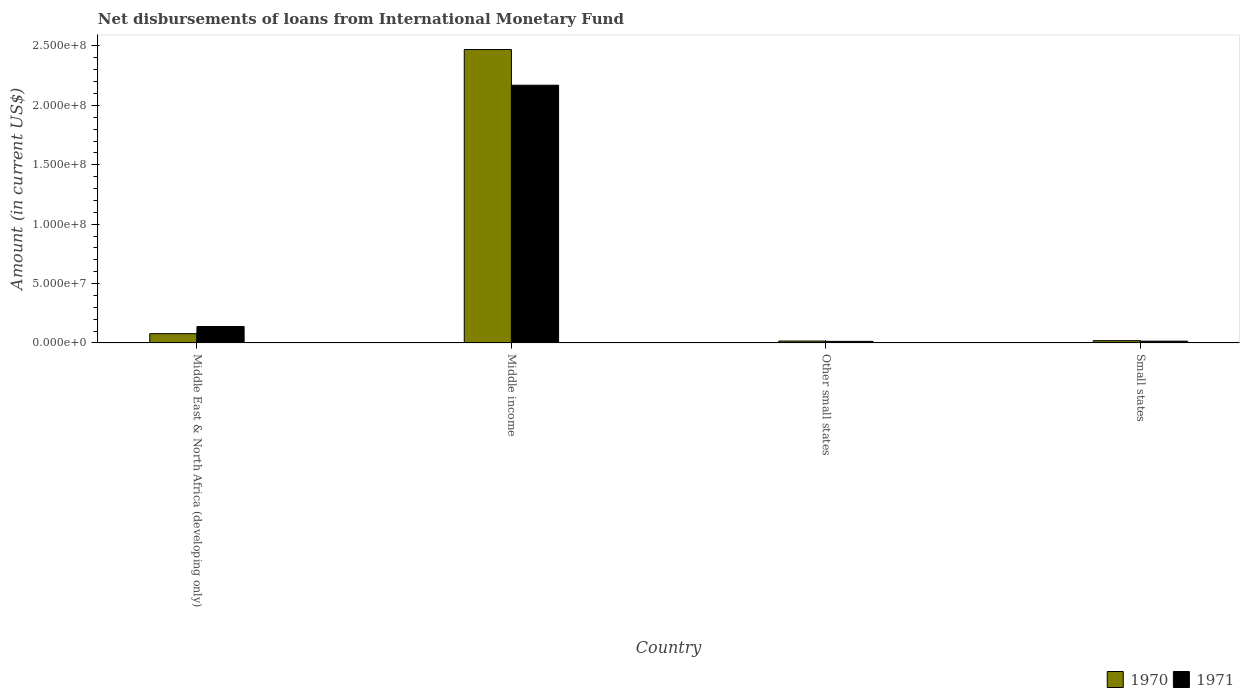How many different coloured bars are there?
Your response must be concise. 2. Are the number of bars per tick equal to the number of legend labels?
Provide a succinct answer. Yes. Are the number of bars on each tick of the X-axis equal?
Offer a terse response. Yes. What is the label of the 3rd group of bars from the left?
Make the answer very short. Other small states. What is the amount of loans disbursed in 1970 in Small states?
Ensure brevity in your answer.  1.91e+06. Across all countries, what is the maximum amount of loans disbursed in 1971?
Provide a succinct answer. 2.17e+08. Across all countries, what is the minimum amount of loans disbursed in 1970?
Provide a succinct answer. 1.61e+06. In which country was the amount of loans disbursed in 1971 minimum?
Your answer should be very brief. Other small states. What is the total amount of loans disbursed in 1970 in the graph?
Your answer should be compact. 2.58e+08. What is the difference between the amount of loans disbursed in 1971 in Middle East & North Africa (developing only) and that in Small states?
Give a very brief answer. 1.23e+07. What is the difference between the amount of loans disbursed in 1970 in Other small states and the amount of loans disbursed in 1971 in Middle East & North Africa (developing only)?
Ensure brevity in your answer.  -1.22e+07. What is the average amount of loans disbursed in 1970 per country?
Your answer should be compact. 6.46e+07. What is the difference between the amount of loans disbursed of/in 1970 and amount of loans disbursed of/in 1971 in Middle East & North Africa (developing only)?
Ensure brevity in your answer.  -6.03e+06. What is the ratio of the amount of loans disbursed in 1971 in Middle East & North Africa (developing only) to that in Other small states?
Your response must be concise. 10.45. Is the difference between the amount of loans disbursed in 1970 in Middle income and Small states greater than the difference between the amount of loans disbursed in 1971 in Middle income and Small states?
Ensure brevity in your answer.  Yes. What is the difference between the highest and the second highest amount of loans disbursed in 1970?
Provide a succinct answer. 2.45e+08. What is the difference between the highest and the lowest amount of loans disbursed in 1970?
Offer a very short reply. 2.45e+08. In how many countries, is the amount of loans disbursed in 1970 greater than the average amount of loans disbursed in 1970 taken over all countries?
Offer a very short reply. 1. What does the 1st bar from the left in Other small states represents?
Offer a terse response. 1970. How many bars are there?
Keep it short and to the point. 8. Are all the bars in the graph horizontal?
Offer a very short reply. No. How many countries are there in the graph?
Your answer should be compact. 4. What is the difference between two consecutive major ticks on the Y-axis?
Provide a short and direct response. 5.00e+07. Are the values on the major ticks of Y-axis written in scientific E-notation?
Provide a succinct answer. Yes. Does the graph contain grids?
Provide a short and direct response. No. How many legend labels are there?
Offer a terse response. 2. How are the legend labels stacked?
Offer a terse response. Horizontal. What is the title of the graph?
Your answer should be compact. Net disbursements of loans from International Monetary Fund. Does "1963" appear as one of the legend labels in the graph?
Ensure brevity in your answer.  No. What is the label or title of the Y-axis?
Your answer should be very brief. Amount (in current US$). What is the Amount (in current US$) in 1970 in Middle East & North Africa (developing only)?
Make the answer very short. 7.79e+06. What is the Amount (in current US$) of 1971 in Middle East & North Africa (developing only)?
Provide a succinct answer. 1.38e+07. What is the Amount (in current US$) of 1970 in Middle income?
Ensure brevity in your answer.  2.47e+08. What is the Amount (in current US$) of 1971 in Middle income?
Offer a very short reply. 2.17e+08. What is the Amount (in current US$) in 1970 in Other small states?
Your answer should be compact. 1.61e+06. What is the Amount (in current US$) in 1971 in Other small states?
Provide a short and direct response. 1.32e+06. What is the Amount (in current US$) in 1970 in Small states?
Your response must be concise. 1.91e+06. What is the Amount (in current US$) of 1971 in Small states?
Give a very brief answer. 1.50e+06. Across all countries, what is the maximum Amount (in current US$) of 1970?
Make the answer very short. 2.47e+08. Across all countries, what is the maximum Amount (in current US$) of 1971?
Your response must be concise. 2.17e+08. Across all countries, what is the minimum Amount (in current US$) of 1970?
Keep it short and to the point. 1.61e+06. Across all countries, what is the minimum Amount (in current US$) of 1971?
Your answer should be compact. 1.32e+06. What is the total Amount (in current US$) of 1970 in the graph?
Your response must be concise. 2.58e+08. What is the total Amount (in current US$) in 1971 in the graph?
Provide a short and direct response. 2.34e+08. What is the difference between the Amount (in current US$) in 1970 in Middle East & North Africa (developing only) and that in Middle income?
Your answer should be compact. -2.39e+08. What is the difference between the Amount (in current US$) of 1971 in Middle East & North Africa (developing only) and that in Middle income?
Your response must be concise. -2.03e+08. What is the difference between the Amount (in current US$) in 1970 in Middle East & North Africa (developing only) and that in Other small states?
Provide a succinct answer. 6.19e+06. What is the difference between the Amount (in current US$) in 1971 in Middle East & North Africa (developing only) and that in Other small states?
Provide a succinct answer. 1.25e+07. What is the difference between the Amount (in current US$) in 1970 in Middle East & North Africa (developing only) and that in Small states?
Keep it short and to the point. 5.89e+06. What is the difference between the Amount (in current US$) in 1971 in Middle East & North Africa (developing only) and that in Small states?
Your answer should be very brief. 1.23e+07. What is the difference between the Amount (in current US$) in 1970 in Middle income and that in Other small states?
Your answer should be very brief. 2.45e+08. What is the difference between the Amount (in current US$) of 1971 in Middle income and that in Other small states?
Offer a very short reply. 2.16e+08. What is the difference between the Amount (in current US$) of 1970 in Middle income and that in Small states?
Ensure brevity in your answer.  2.45e+08. What is the difference between the Amount (in current US$) of 1971 in Middle income and that in Small states?
Make the answer very short. 2.15e+08. What is the difference between the Amount (in current US$) of 1970 in Other small states and that in Small states?
Provide a succinct answer. -2.99e+05. What is the difference between the Amount (in current US$) in 1971 in Other small states and that in Small states?
Your answer should be very brief. -1.76e+05. What is the difference between the Amount (in current US$) of 1970 in Middle East & North Africa (developing only) and the Amount (in current US$) of 1971 in Middle income?
Give a very brief answer. -2.09e+08. What is the difference between the Amount (in current US$) in 1970 in Middle East & North Africa (developing only) and the Amount (in current US$) in 1971 in Other small states?
Provide a succinct answer. 6.47e+06. What is the difference between the Amount (in current US$) of 1970 in Middle East & North Africa (developing only) and the Amount (in current US$) of 1971 in Small states?
Your response must be concise. 6.30e+06. What is the difference between the Amount (in current US$) of 1970 in Middle income and the Amount (in current US$) of 1971 in Other small states?
Keep it short and to the point. 2.46e+08. What is the difference between the Amount (in current US$) of 1970 in Middle income and the Amount (in current US$) of 1971 in Small states?
Your answer should be compact. 2.46e+08. What is the difference between the Amount (in current US$) of 1970 in Other small states and the Amount (in current US$) of 1971 in Small states?
Your answer should be very brief. 1.09e+05. What is the average Amount (in current US$) of 1970 per country?
Your answer should be compact. 6.46e+07. What is the average Amount (in current US$) of 1971 per country?
Give a very brief answer. 5.84e+07. What is the difference between the Amount (in current US$) of 1970 and Amount (in current US$) of 1971 in Middle East & North Africa (developing only)?
Your answer should be compact. -6.03e+06. What is the difference between the Amount (in current US$) of 1970 and Amount (in current US$) of 1971 in Middle income?
Make the answer very short. 3.00e+07. What is the difference between the Amount (in current US$) in 1970 and Amount (in current US$) in 1971 in Other small states?
Your answer should be compact. 2.85e+05. What is the difference between the Amount (in current US$) in 1970 and Amount (in current US$) in 1971 in Small states?
Give a very brief answer. 4.08e+05. What is the ratio of the Amount (in current US$) in 1970 in Middle East & North Africa (developing only) to that in Middle income?
Make the answer very short. 0.03. What is the ratio of the Amount (in current US$) in 1971 in Middle East & North Africa (developing only) to that in Middle income?
Ensure brevity in your answer.  0.06. What is the ratio of the Amount (in current US$) of 1970 in Middle East & North Africa (developing only) to that in Other small states?
Ensure brevity in your answer.  4.85. What is the ratio of the Amount (in current US$) in 1971 in Middle East & North Africa (developing only) to that in Other small states?
Keep it short and to the point. 10.45. What is the ratio of the Amount (in current US$) in 1970 in Middle East & North Africa (developing only) to that in Small states?
Offer a very short reply. 4.09. What is the ratio of the Amount (in current US$) of 1971 in Middle East & North Africa (developing only) to that in Small states?
Your answer should be very brief. 9.23. What is the ratio of the Amount (in current US$) in 1970 in Middle income to that in Other small states?
Keep it short and to the point. 153.71. What is the ratio of the Amount (in current US$) in 1971 in Middle income to that in Other small states?
Ensure brevity in your answer.  164.14. What is the ratio of the Amount (in current US$) of 1970 in Middle income to that in Small states?
Your answer should be compact. 129.6. What is the ratio of the Amount (in current US$) in 1971 in Middle income to that in Small states?
Give a very brief answer. 144.85. What is the ratio of the Amount (in current US$) in 1970 in Other small states to that in Small states?
Your answer should be very brief. 0.84. What is the ratio of the Amount (in current US$) of 1971 in Other small states to that in Small states?
Keep it short and to the point. 0.88. What is the difference between the highest and the second highest Amount (in current US$) of 1970?
Offer a very short reply. 2.39e+08. What is the difference between the highest and the second highest Amount (in current US$) of 1971?
Keep it short and to the point. 2.03e+08. What is the difference between the highest and the lowest Amount (in current US$) of 1970?
Provide a succinct answer. 2.45e+08. What is the difference between the highest and the lowest Amount (in current US$) of 1971?
Your response must be concise. 2.16e+08. 